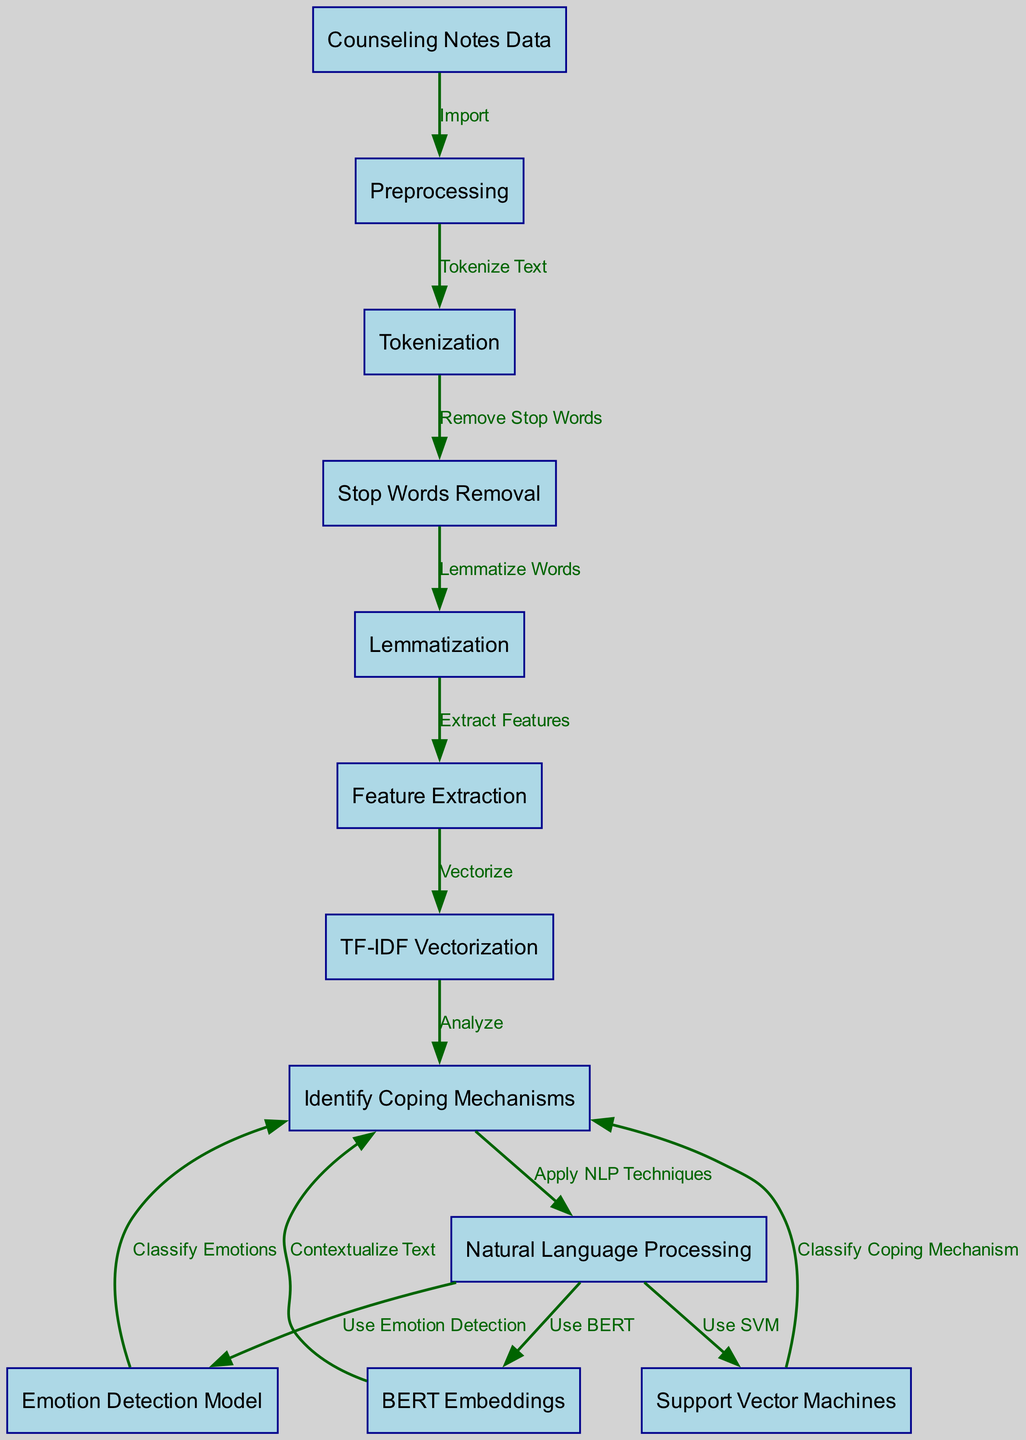What is the first step in the diagram? The first step in the diagram is "Counseling Notes Data." This is indicated as the starting point from which the whole process begins, leading to the preprocessing stage.
Answer: Counseling Notes Data How many nodes are present in the diagram? The diagram contains a total of twelve nodes, each representing a specific component or step in the machine learning process for identifying coping mechanisms.
Answer: Twelve What type of model is used for emotion detection in this diagram? The diagram specifies an "Emotion Detection Model" as the type used for analyzing emotions within the counseling notes after applying natural language processing techniques.
Answer: Emotion Detection Model Which method is utilized for feature extraction? The diagram shows that "TF-IDF Vectorization" is the method used for feature extraction, as indicated by the pathway from "Feature Extraction" to "TF-IDF Vectorization."
Answer: TF-IDF Vectorization What follows after the stop words removal step? After the "Stop Words Removal" step, the next process is "Lemmatization." This indicates that words are simplified to their base forms immediately after unnecessary words are removed.
Answer: Lemmatization Which technique is applied to contextualize text before identifying coping mechanisms? The diagram indicates that "BERT Embeddings" is specifically applied to contextualize the text, providing a deep understanding before proceeding to identify coping mechanisms.
Answer: BERT Embeddings How are coping mechanisms classified in this diagram? Coping mechanisms are classified by using "Support Vector Machines," which is shown as the method used to analyze the processed notes and determine effective coping strategies.
Answer: Support Vector Machines Which step involves the removal of unnecessary words? The step that involves the removal of unnecessary words is "Stop Words Removal," clearly marked in the diagram as a preprocessing stage before moving to lemmatization.
Answer: Stop Words Removal What are the main techniques applied under natural language processing in this diagram? The diagram illustrates that the main techniques applied under natural language processing include emotion detection, support vector machines, and BERT embeddings, all connecting back to the node for analyzing coping mechanisms.
Answer: Emotion detection, Support Vector Machines, BERT Embeddings 